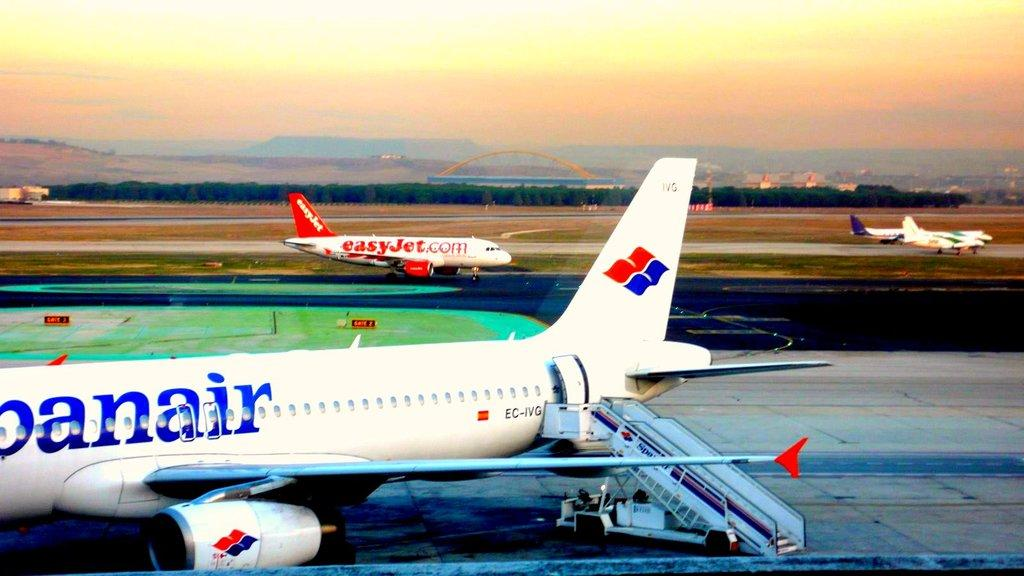What is the main subject of the image? The main subject of the image is aeroplanes. What are the aeroplanes doing in the image? The aeroplanes are moving on a road in the image. Where might this image have been taken? The location appears to be an airport, as indicated by the presence of aeroplanes and a road for them to move on. What can be seen in the background of the image? There are trees and hills in the background of the image, along with the sky. How many cherries can be seen on the seat of the aeroplane in the image? There are no cherries or seats visible in the image; it only shows aeroplanes moving on a road. What type of parcel is being delivered by the aeroplane in the image? There is no parcel being delivered by an aeroplane in the image; it only shows aeroplanes moving on a road. 